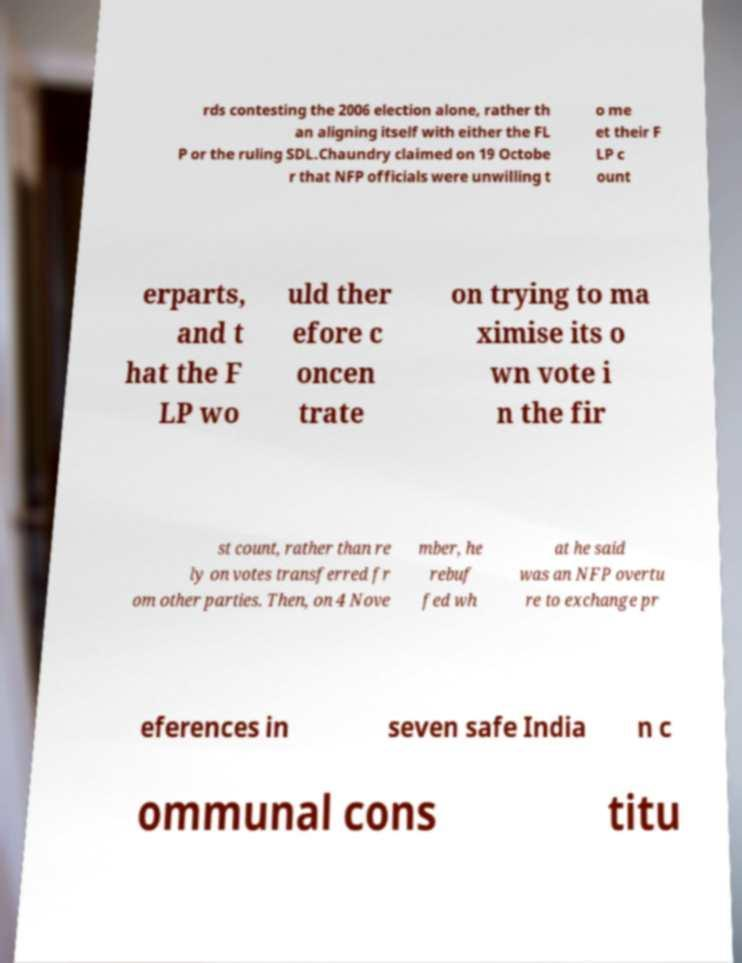Could you extract and type out the text from this image? rds contesting the 2006 election alone, rather th an aligning itself with either the FL P or the ruling SDL.Chaundry claimed on 19 Octobe r that NFP officials were unwilling t o me et their F LP c ount erparts, and t hat the F LP wo uld ther efore c oncen trate on trying to ma ximise its o wn vote i n the fir st count, rather than re ly on votes transferred fr om other parties. Then, on 4 Nove mber, he rebuf fed wh at he said was an NFP overtu re to exchange pr eferences in seven safe India n c ommunal cons titu 